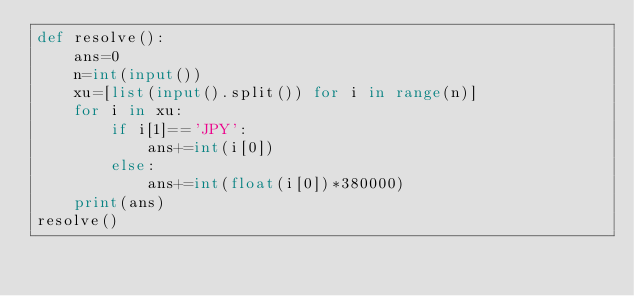<code> <loc_0><loc_0><loc_500><loc_500><_Python_>def resolve():
	ans=0
	n=int(input())
	xu=[list(input().split()) for i in range(n)]
	for i in xu:
		if i[1]=='JPY':
			ans+=int(i[0])
		else:
			ans+=int(float(i[0])*380000)
	print(ans)
resolve()</code> 